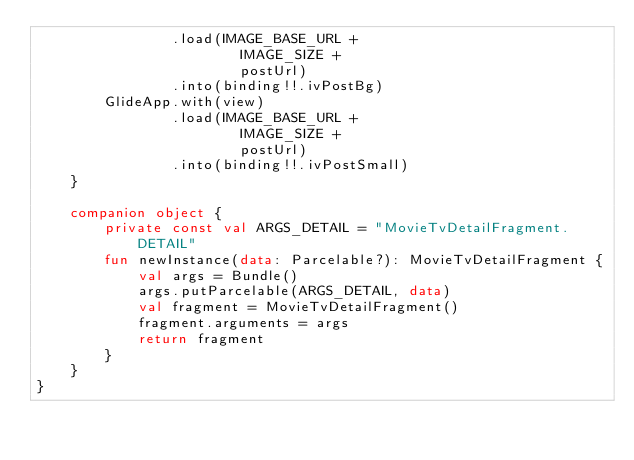<code> <loc_0><loc_0><loc_500><loc_500><_Kotlin_>                .load(IMAGE_BASE_URL +
                        IMAGE_SIZE +
                        postUrl)
                .into(binding!!.ivPostBg)
        GlideApp.with(view)
                .load(IMAGE_BASE_URL +
                        IMAGE_SIZE +
                        postUrl)
                .into(binding!!.ivPostSmall)
    }

    companion object {
        private const val ARGS_DETAIL = "MovieTvDetailFragment.DETAIL"
        fun newInstance(data: Parcelable?): MovieTvDetailFragment {
            val args = Bundle()
            args.putParcelable(ARGS_DETAIL, data)
            val fragment = MovieTvDetailFragment()
            fragment.arguments = args
            return fragment
        }
    }
}</code> 